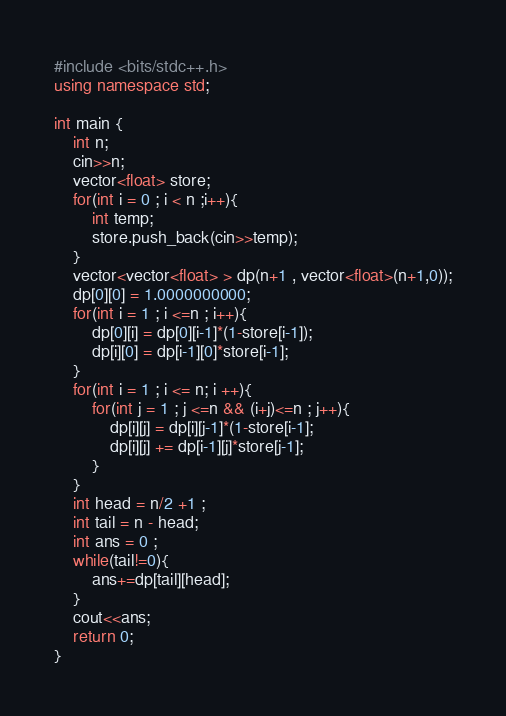<code> <loc_0><loc_0><loc_500><loc_500><_C++_>#include <bits/stdc++.h>
using namespace std;

int main {
	int n;
	cin>>n;
	vector<float> store;
	for(int i = 0 ; i < n ;i++){
		int temp;
		store.push_back(cin>>temp);
	}                                                            
	vector<vector<float> > dp(n+1 , vector<float>(n+1,0));
	dp[0][0] = 1.0000000000;
	for(int i = 1 ; i <=n ; i++){
		dp[0][i] = dp[0][i-1]*(1-store[i-1]); 
		dp[i][0] = dp[i-1][0]*store[i-1];
	}
	for(int i = 1 ; i <= n; i ++){
		for(int j = 1 ; j <=n && (i+j)<=n ; j++){
			dp[i][j] = dp[i][j-1]*(1-store[i-1];
			dp[i][j] += dp[i-1][j]*store[j-1];
		}
	}
	int head = n/2 +1 ;
	int tail = n - head;
	int ans = 0 ;
	while(tail!=0){
		ans+=dp[tail][head];
	}
	cout<<ans;
	return 0;
}</code> 